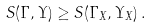Convert formula to latex. <formula><loc_0><loc_0><loc_500><loc_500>S ( \Gamma , \Upsilon ) \geq S ( \Gamma _ { X } , \Upsilon _ { X } ) \, .</formula> 